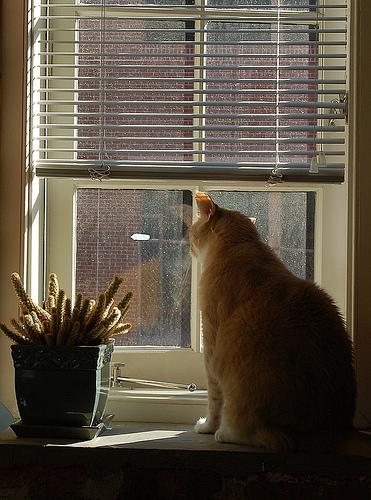Why is the cat on the sill?
Concise answer only. Looking out window. Does this photo suggest isolation?
Concise answer only. Yes. Are there curtains on the window?
Short answer required. No. 